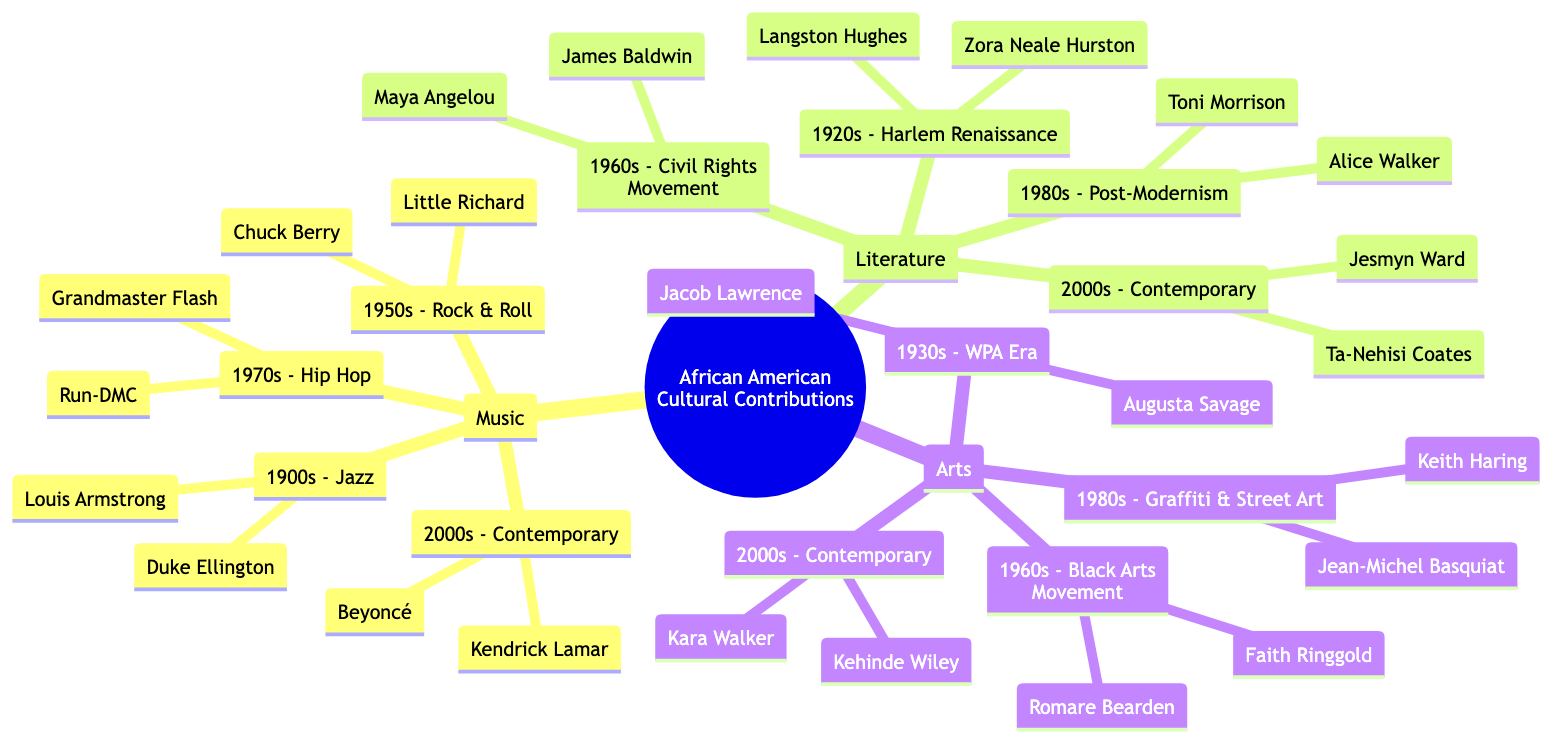What major music genre emerged in the 1950s? The diagram indicates that the major music genre that emerged in the 1950s is Rock & Roll. This can be found under the Music category, where the decade is clearly associated with this genre.
Answer: Rock & Roll Who are the key personalities of the Harlem Renaissance? The key personalities of the Harlem Renaissance are Langston Hughes and Zora Neale Hurston. These names are listed under the Literature category for the 1920s section in the diagram.
Answer: Langston Hughes, Zora Neale Hurston In which decade did Hip Hop emerge? The diagram states that Hip Hop emerged in the 1970s. This information is found in the Music category and specifically links the genre to that decade.
Answer: 1970s How many key personalities are listed under the Arts category for the 2000s? Under the Arts category for the 2000s, there are two key personalities specified: Kara Walker and Kehinde Wiley. This counts as the number of personalities listed in that section.
Answer: 2 Which art movement was prominent in the 1960s? The prominent art movement in the 1960s listed in the diagram is the Black Arts Movement. This is noted under the Arts category for that specific decade.
Answer: Black Arts Movement Which contemporary writer is mentioned in the Literature section? The contemporary writer mentioned in the Literature section is Ta-Nehisi Coates. This detail can be found under the 2000s subsection of Literature in the diagram.
Answer: Ta-Nehisi Coates Who are the two musicians associated with Jazz in the 1900s? The two musicians associated with Jazz in the 1900s are Louis Armstrong and Duke Ellington. These names appear in the Music section under that specific decade.
Answer: Louis Armstrong, Duke Ellington Which decade corresponds with Jean-Michel Basquiat's contribution to art? According to the diagram, Jean-Michel Basquiat's contributions to art are associated with the 1980s, specifically within the context of Graffiti & Street Art in the Arts section.
Answer: 1980s What genre is represented by Beyoncé? Beyoncé is represented under the Contemporary genre in the Music section. This indicates that she is linked with modern musical contributions.
Answer: Contemporary 